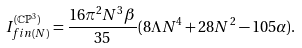<formula> <loc_0><loc_0><loc_500><loc_500>I _ { f i n ( N ) } ^ { ( \mathbb { C P } ^ { 3 } ) } = \frac { 1 6 \pi ^ { 2 } N ^ { 3 } \beta } { 3 5 } ( 8 \Lambda N ^ { 4 } + 2 8 N ^ { 2 } - 1 0 5 \alpha ) .</formula> 